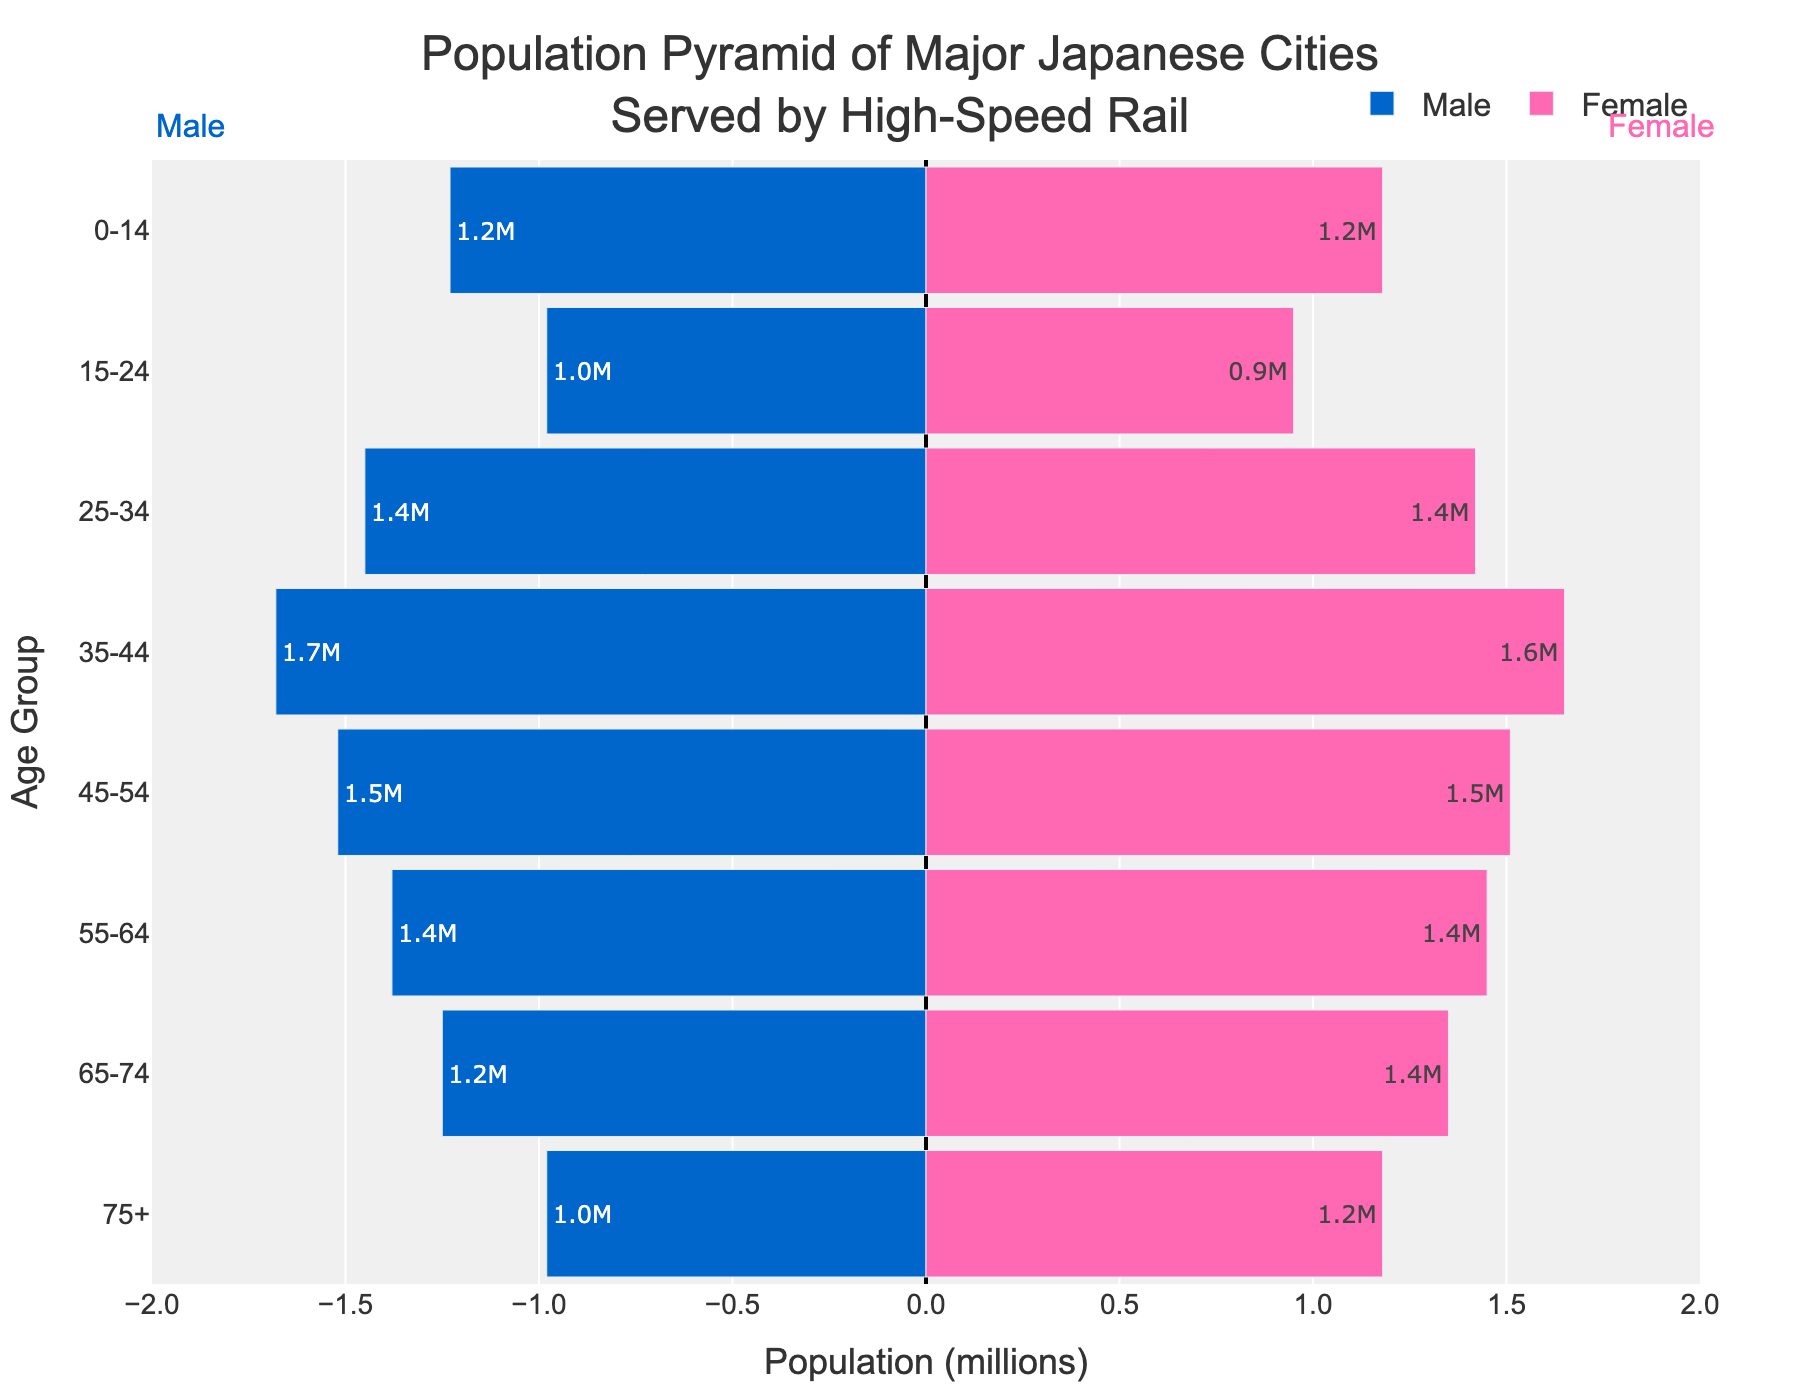What is the title of the figure? The title is at the top of the figure. It reads "Population Pyramid of Major Japanese Cities Served by High-Speed Rail".
Answer: Population Pyramid of Major Japanese Cities Served by High-Speed Rail How many age groups are displayed in the figure? Count the different age group labels on the y-axis. These are "0-14", "15-24", "25-34", "35-44", "45-54", "55-64", "65-74", "75+". There are eight age groups in total.
Answer: Eight Which age group has the highest female population? Locate the tallest bar on the right side of the pyramid. The age group "35-44" has the highest female population with about 1.65 million.
Answer: 35-44 What is the total population for the age group 25-34? Add the population of males and females for the age group "25-34" by summing their absolute values. The male population is 1.45 million and the female population is 1.42 million, so the total is 1.45 + 1.42 = 2.87 million.
Answer: 2.87 million Which age group has a larger male population compared to female population? Compare the lengths of bars for males and females within each age group. The "0-14" age group has a larger male population (1.23 million) compared to the female population (1.18 million).
Answer: 0-14 What is the difference in the population of males and females in the "75+" age group? Subtract the male population from the female population for the age group "75+". The female population is 1.18 million and the male population is 0.98 million, so the difference is 1.18 - 0.98 = 0.2 million.
Answer: 0.2 million What percentage of the population in the age group 35-44 is male? First, find the total population for the age group "35-44", which is 1.68 million (male) + 1.65 million (female) = 3.33 million. Then, calculate the percentage of males: (1.68 / 3.33) * 100 ≈ 50.45%.
Answer: 50.45% What is the total working-age population (ages 15-64)? Sum the total populations for people between the ages of 15-64. The values in millions are as follows: Males: 0.98 + 1.45 + 1.68 + 1.52 + 1.38 = 7.01, Females: 0.95 + 1.42 + 1.65 + 1.51 + 1.45 = 6.98. The total working-age population is 7.01 + 6.98 = 13.99 million.
Answer: 13.99 million How does the population of males aged 25-34 compare to those aged 45-54? Compare the length of the male bars for these two age groups. For "25-34", the male population is 1.45 million, and for "45-54", it is 1.52 million. The "45-54" age group has a slightly higher male population.
Answer: 45-54 